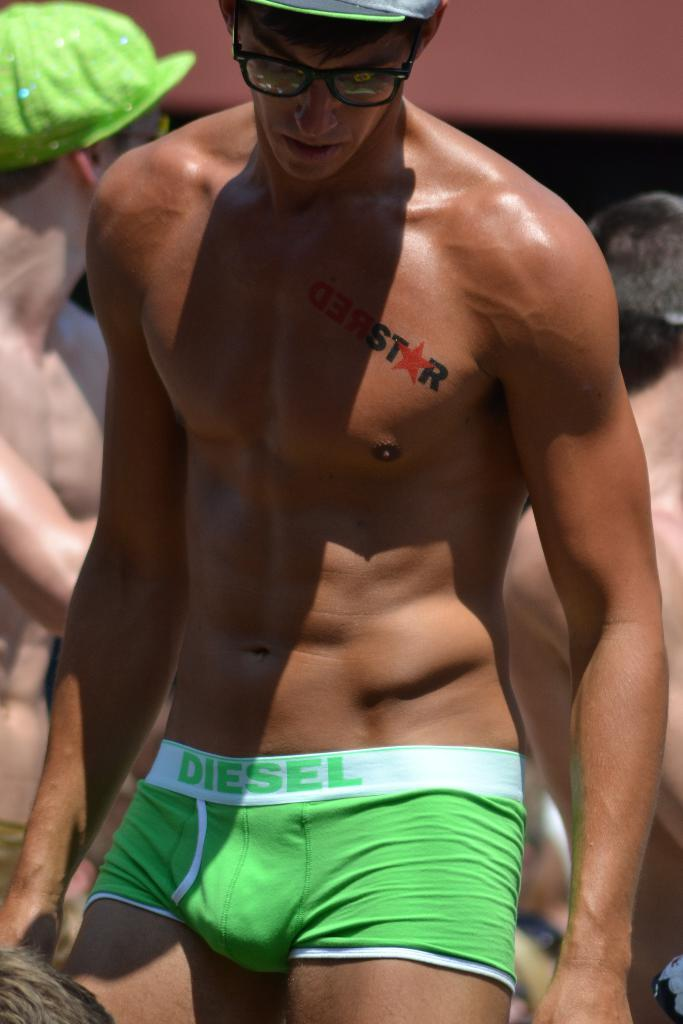<image>
Describe the image concisely. Man that is shirtless with a "RedStar" tattoo. 